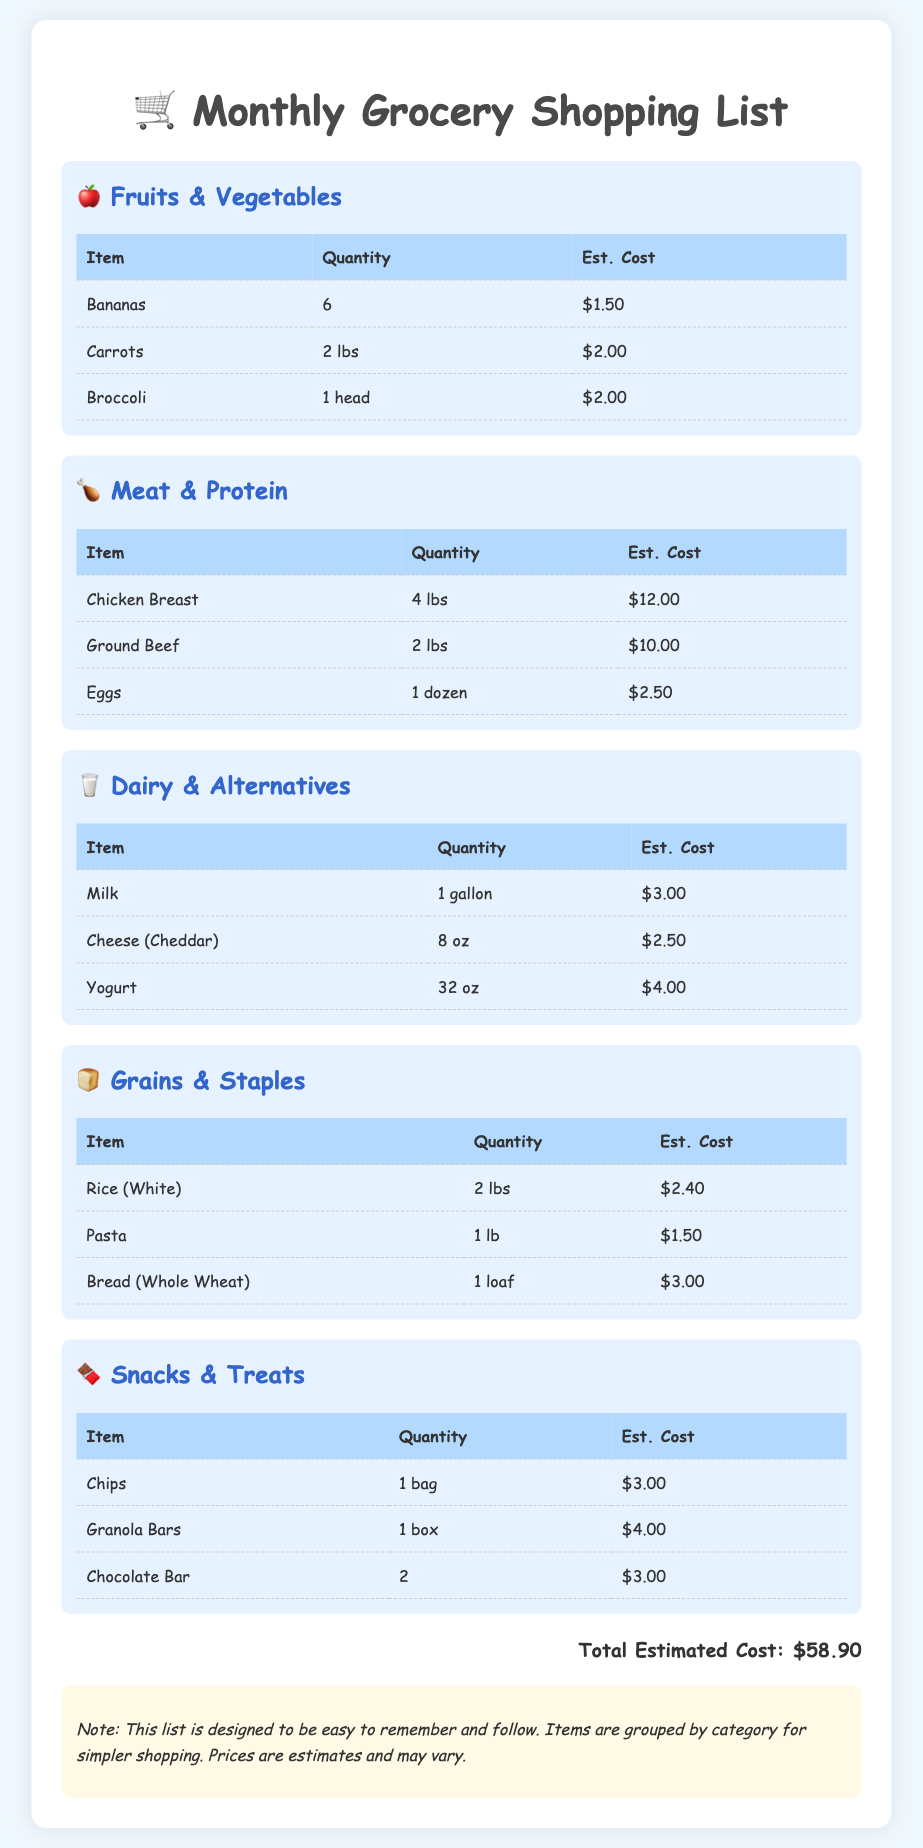What is the estimated cost of bananas? The estimated cost of bananas is listed in the Fruits & Vegetables section of the document.
Answer: $1.50 How many pounds of chicken breast are included? The quantity of chicken breast is specified in the Meat & Protein section of the document.
Answer: 4 lbs What is the total estimated cost of the grocery shopping list? The total estimated cost is provided at the end of the document as the sum of all itemized costs.
Answer: $58.90 How many items are listed in the Dairy & Alternatives category? By counting the rows under the Dairy & Alternatives section, we see the number of items listed.
Answer: 3 What type of bread is included in the Grains & Staples category? The type of bread is mentioned in the Grains & Staples section of the document.
Answer: Whole Wheat What is the cost of the meat section? The estimated costs of all items in the Meat & Protein section are summed to find the total cost of this category.
Answer: $24.50 How many bags of chips are on the list? The number of bags of chips is found in the Snacks & Treats section of the document.
Answer: 1 bag What is the estimated cost of yogurt? The estimated cost of yogurt can be found in the Dairy & Alternatives section.
Answer: $4.00 